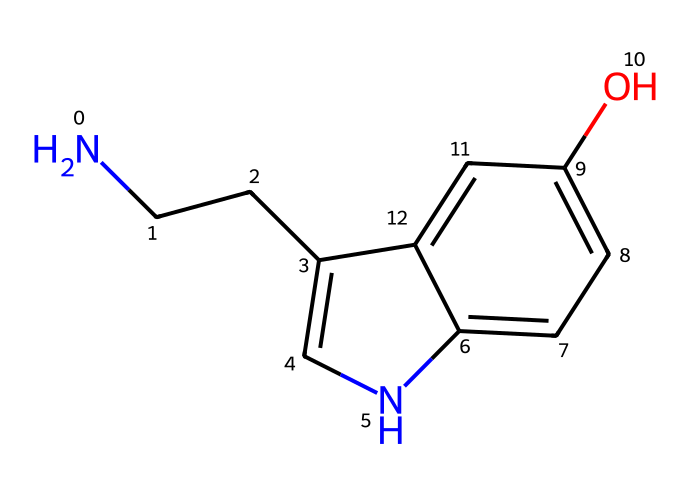What is the molecular formula of serotonin? The molecular formula can be determined by counting all the atoms present in the SMILES representation. The SMILES code indicates there are carbon (C), hydrogen (H), nitrogen (N), and oxygen (O) atoms in the structure. After counting, the formula is found to be C10H12N2O.
Answer: C10H12N2O How many chiral centers are in serotonin? A chiral center is typically a carbon atom bonded to four different substituents. In the given structure, upon analyzing the carbon atoms, it is found that there is one carbon atom that meets this criterion.
Answer: 1 What type of amine is present in serotonin? The structure has a primary amine as indicated by the presence of a nitrogen atom bound to one carbon atom and two hydrogen atoms. This suggests it is a primary amine.
Answer: primary How many aromatic rings are present in the structure of serotonin? The structure shows two distinct aromatic rings, which can be identified by the alternating double bonds in the cyclic portions. Counting these gives us the total number of aromatic rings.
Answer: 2 Is serotonin a chiral compound? Serotonin possesses a chiral center, making it a chiral compound. The presence of this center allows it to exist in two non-superimposable mirror forms (enantiomers).
Answer: Yes What functional group is indicated by the -OH present in serotonin? An -OH group is known as a hydroxyl group, which typically indicates that the compound has alcohol characteristics. The presence of this group can be confirmed by looking at the structure.
Answer: hydroxyl 